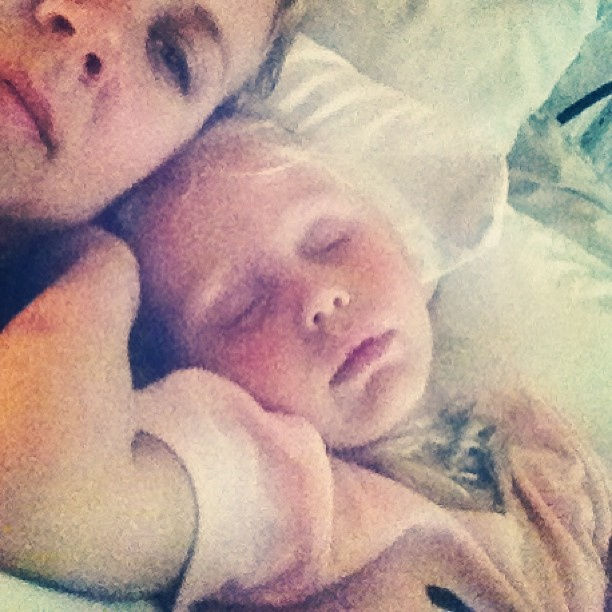Describe the objects in this image and their specific colors. I can see people in salmon, tan, darkgray, and gray tones, bed in salmon, beige, darkgray, and tan tones, and people in salmon, lightpink, brown, darkgray, and gray tones in this image. 